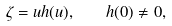Convert formula to latex. <formula><loc_0><loc_0><loc_500><loc_500>\zeta = u h ( u ) , \quad h ( 0 ) \neq 0 ,</formula> 